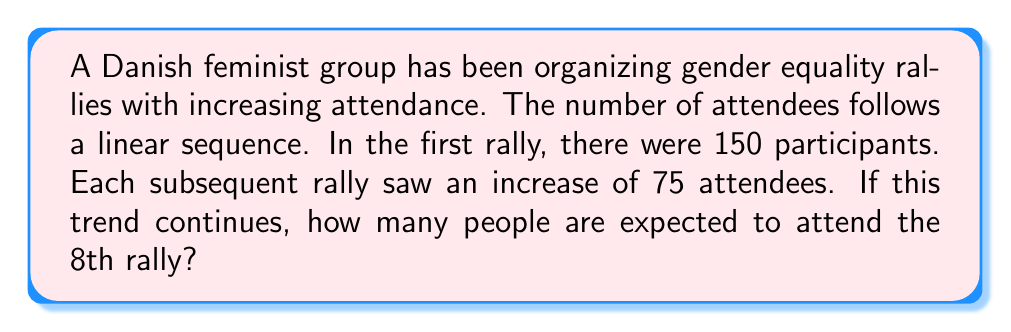Teach me how to tackle this problem. Let's approach this step-by-step:

1) We're dealing with an arithmetic sequence where:
   - First term (a₁) = 150
   - Common difference (d) = 75

2) The general formula for the nth term of an arithmetic sequence is:
   $$ a_n = a_1 + (n-1)d $$

3) We want to find the 8th term (n = 8), so let's substitute:
   $$ a_8 = 150 + (8-1)75 $$

4) Simplify:
   $$ a_8 = 150 + (7)75 $$

5) Calculate:
   $$ a_8 = 150 + 525 = 675 $$

Therefore, if the trend continues, 675 people are expected to attend the 8th rally.
Answer: 675 attendees 